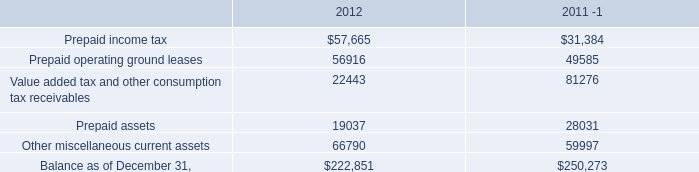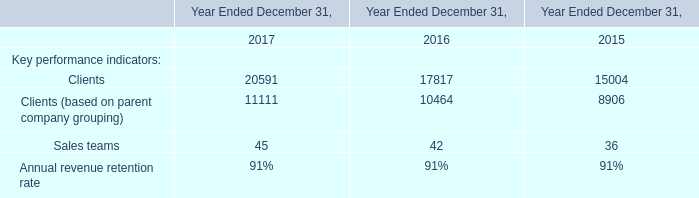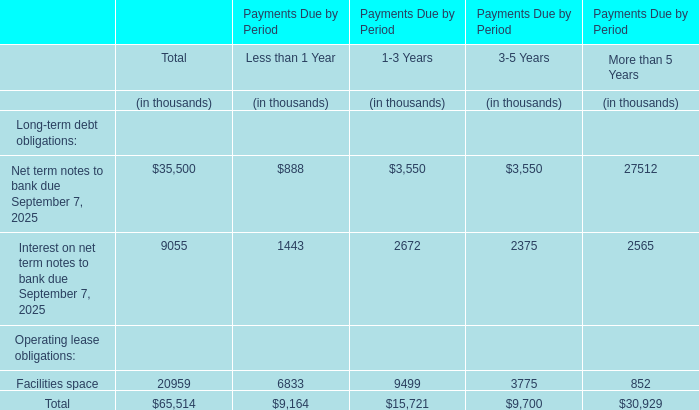what's the total amount of Clients of Year Ended December 31, 2017, and Value added tax and other consumption tax receivables of 2012 ? 
Computations: (20591.0 + 22443.0)
Answer: 43034.0. 